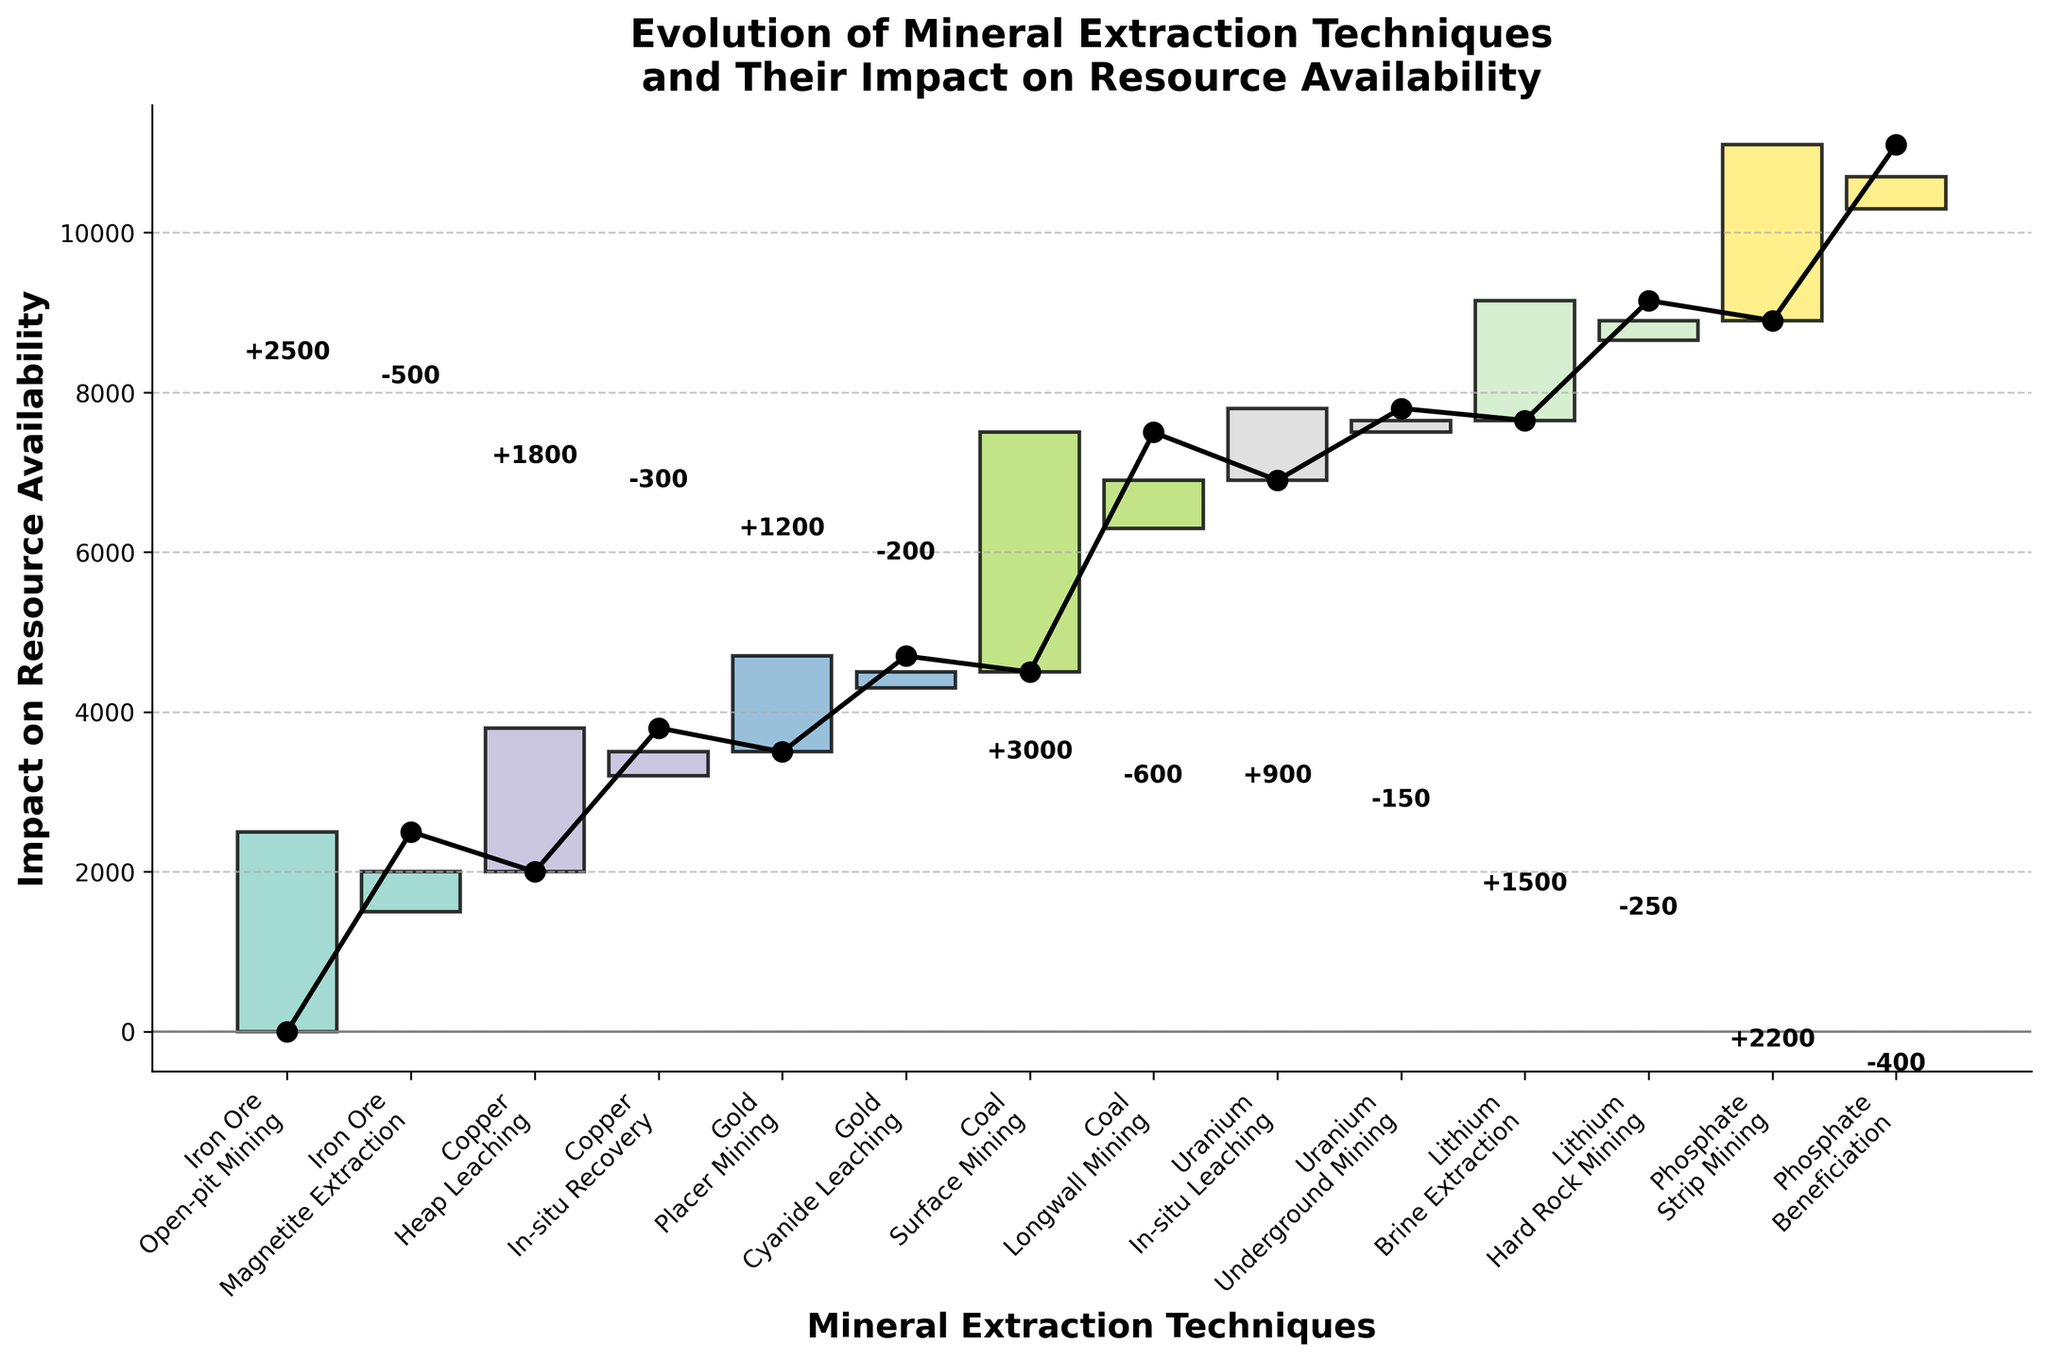**Question 1**: What is the title of the chart? The title of the chart is usually written at the top and gives a brief description of what the chart is about. In this case, you can see the title at the top of the figure stating the key point of the visualization.
Answer: Evolution of Mineral Extraction Techniques and Their Impact on Resource Availability **Question 2**: How many different minerals are represented in the chart? Each mineral is represented by a unique color in the chart. By counting these unique colors in the legend or the plot, we can determine the number of different minerals.
Answer: 6 **Question 3**: What extraction technique has the highest positive impact on resource availability? To find this, look at the bars with positive impacts and identify the bar with the greatest height.
Answer: Surface Mining for Coal **Question 4**: Which mineral's extraction technique results in the greatest reduction in resource availability? Check the bars with negative impacts and identify the one that drops the furthest below the x-axis.
Answer: Iron Ore through Magnetite Extraction **Question 5**: What is the cumulative impact of Copper extraction techniques on resource availability? Sum the impacts of all extraction techniques for Copper: 1800 (Heap Leaching) + (-300) (In-situ Recovery).
Answer: +1500 **Question 6**: Which technique caused a positive shift in Gold resource availability? Look at the techniques listed under Gold in the x-axis labels and find the one with a positive bar above the x-axis.
Answer: Placer Mining **Question 7**: Compare the impact of Phosphate's extraction techniques on resource availability. Which has a greater impact? Compare the heights of the bars for Strip Mining and Beneficiation for Phosphate. Strip Mining’s bar height (+2200) is greater than Beneficiation’s (-400).
Answer: Strip Mining **Question 8**: By how much does Uranium extraction increase resource availability? Sum the impacts of all extraction techniques for Uranium: 900 (In-situ Leaching) + (-150) (Underground Mining).
Answer: +750 **Question 9**: What is the initial cumulative impact on resource availability before any technique is applied? The initial cumulative impact is always zero because no technique has been applied yet, as indicated by the starting point on the plot.
Answer: 0 **Question 10**: Determine the overall impact on resource availability after applying all techniques sequentially from the start to end of the chart. Sum the impacts of all techniques listed in the chart:
2500 (Open-pit Mining) + (-500) (Magnetite Extraction) + 1800 (Heap Leaching) + (-300) (In-situ Recovery) + 1200 (Placer Mining) + (-200) (Cyanide Leaching) + 3000 (Surface Mining) + (-600) (Longwall Mining) + 900 (In-situ Leaching) + (-150) (Underground Mining) + 1500 (Brine Extraction) + (-250) (Hard Rock Mining) + 2200 (Strip Mining) + (-400) (Beneficiation) = 9200. Steps: 
1. Identify each impact from the bars.
2. Sum the positive and negative values.
3. Calculate the resulting cumulative impact.
Answer: +9200 